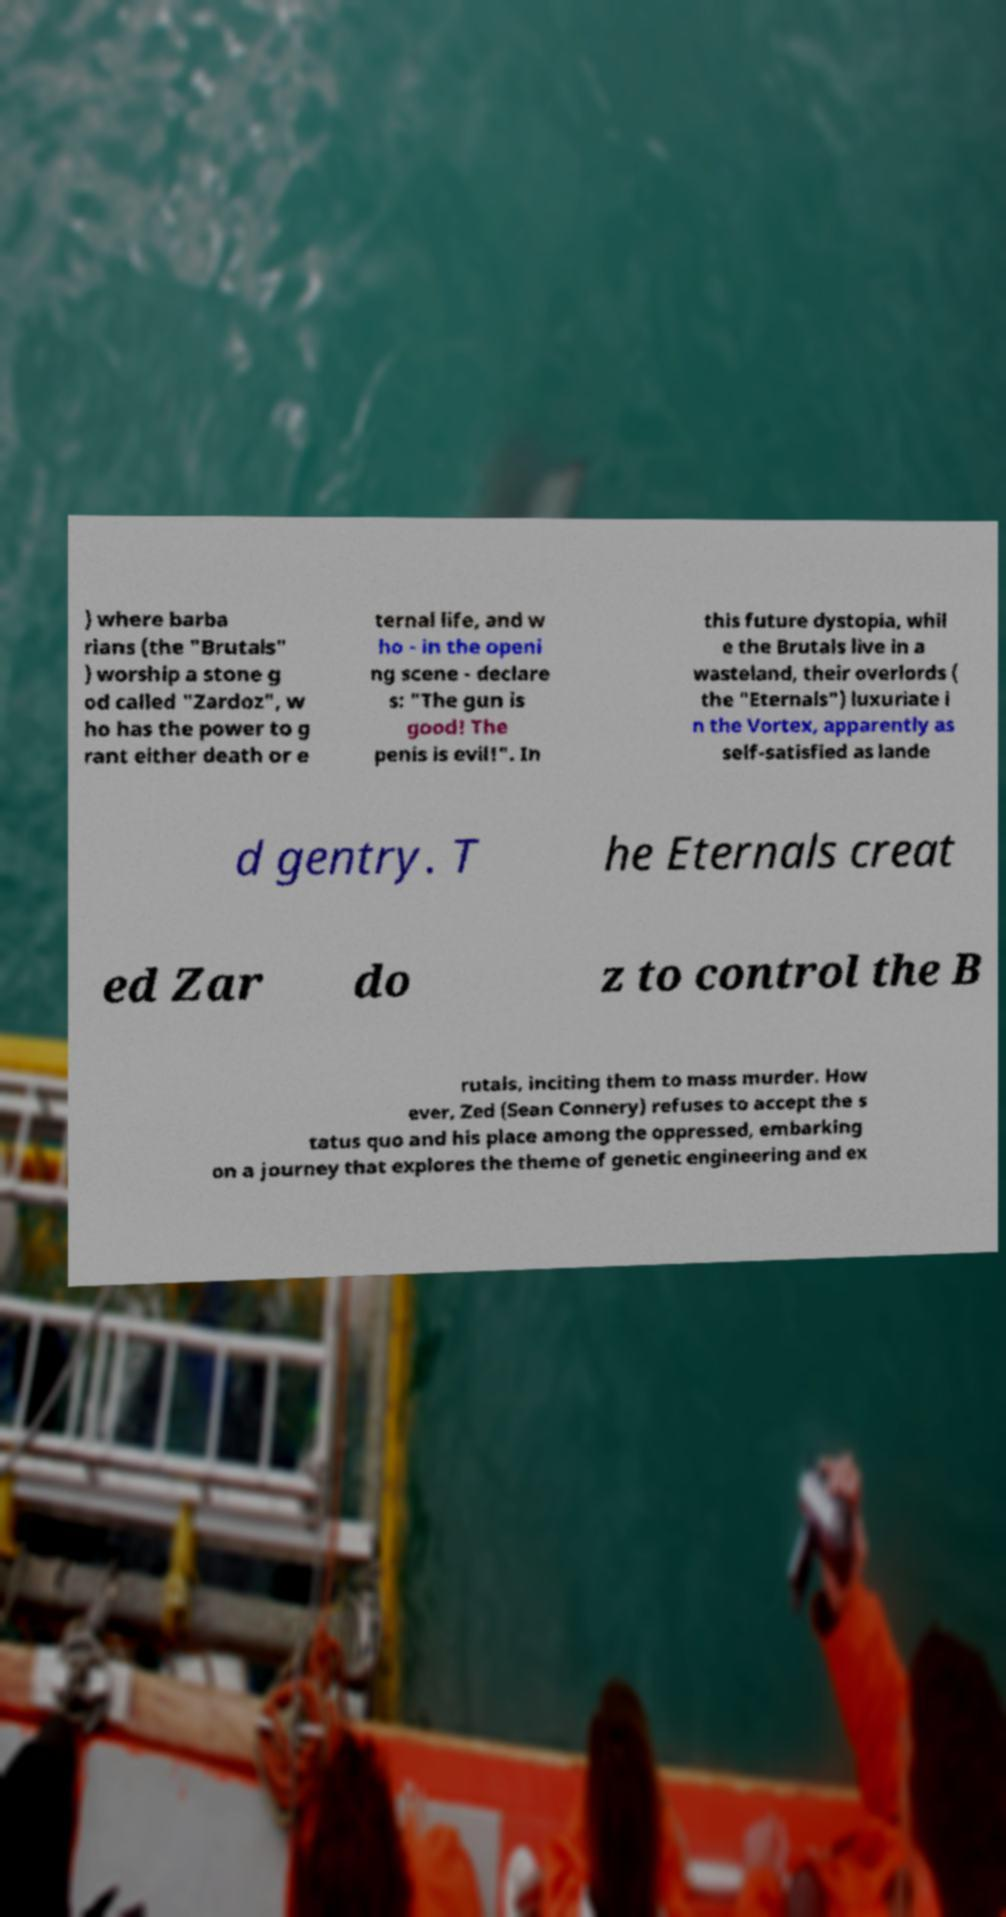For documentation purposes, I need the text within this image transcribed. Could you provide that? ) where barba rians (the "Brutals" ) worship a stone g od called "Zardoz", w ho has the power to g rant either death or e ternal life, and w ho - in the openi ng scene - declare s: "The gun is good! The penis is evil!". In this future dystopia, whil e the Brutals live in a wasteland, their overlords ( the "Eternals") luxuriate i n the Vortex, apparently as self-satisfied as lande d gentry. T he Eternals creat ed Zar do z to control the B rutals, inciting them to mass murder. How ever, Zed (Sean Connery) refuses to accept the s tatus quo and his place among the oppressed, embarking on a journey that explores the theme of genetic engineering and ex 